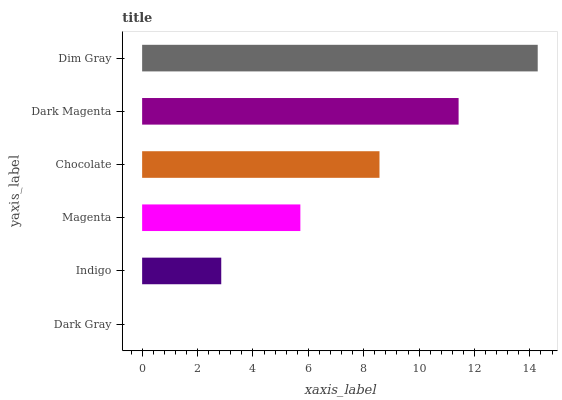Is Dark Gray the minimum?
Answer yes or no. Yes. Is Dim Gray the maximum?
Answer yes or no. Yes. Is Indigo the minimum?
Answer yes or no. No. Is Indigo the maximum?
Answer yes or no. No. Is Indigo greater than Dark Gray?
Answer yes or no. Yes. Is Dark Gray less than Indigo?
Answer yes or no. Yes. Is Dark Gray greater than Indigo?
Answer yes or no. No. Is Indigo less than Dark Gray?
Answer yes or no. No. Is Chocolate the high median?
Answer yes or no. Yes. Is Magenta the low median?
Answer yes or no. Yes. Is Magenta the high median?
Answer yes or no. No. Is Chocolate the low median?
Answer yes or no. No. 